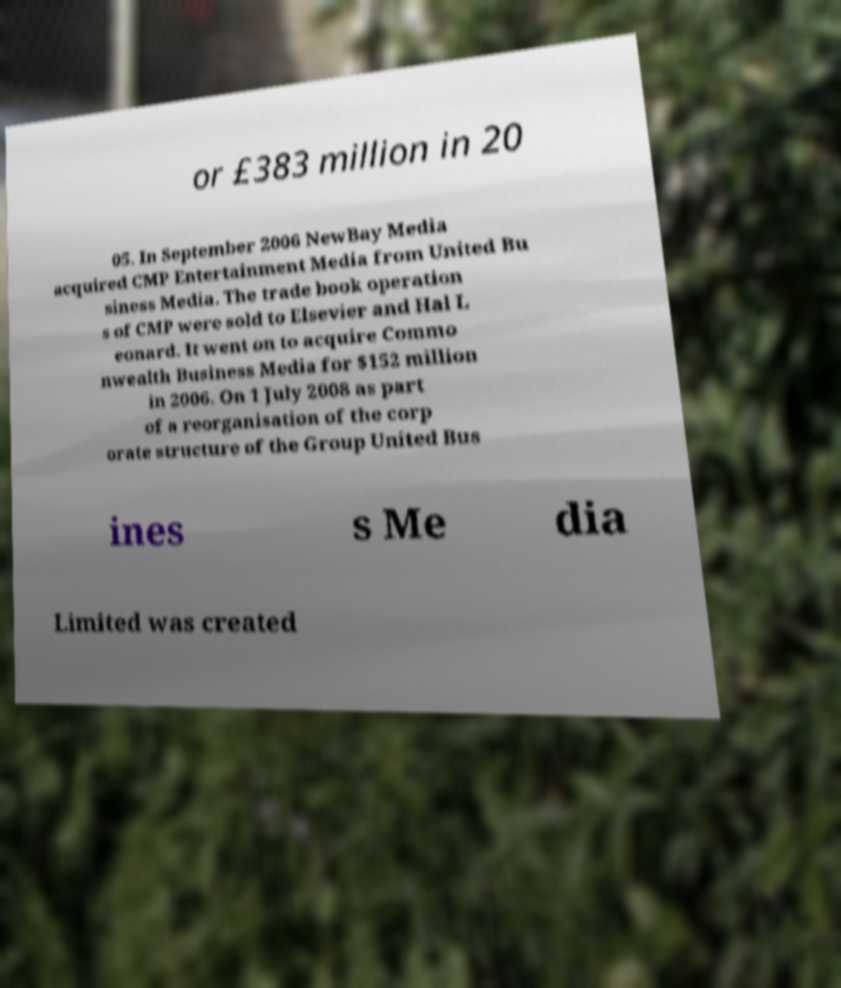There's text embedded in this image that I need extracted. Can you transcribe it verbatim? or £383 million in 20 05. In September 2006 NewBay Media acquired CMP Entertainment Media from United Bu siness Media. The trade book operation s of CMP were sold to Elsevier and Hal L eonard. It went on to acquire Commo nwealth Business Media for $152 million in 2006. On 1 July 2008 as part of a reorganisation of the corp orate structure of the Group United Bus ines s Me dia Limited was created 